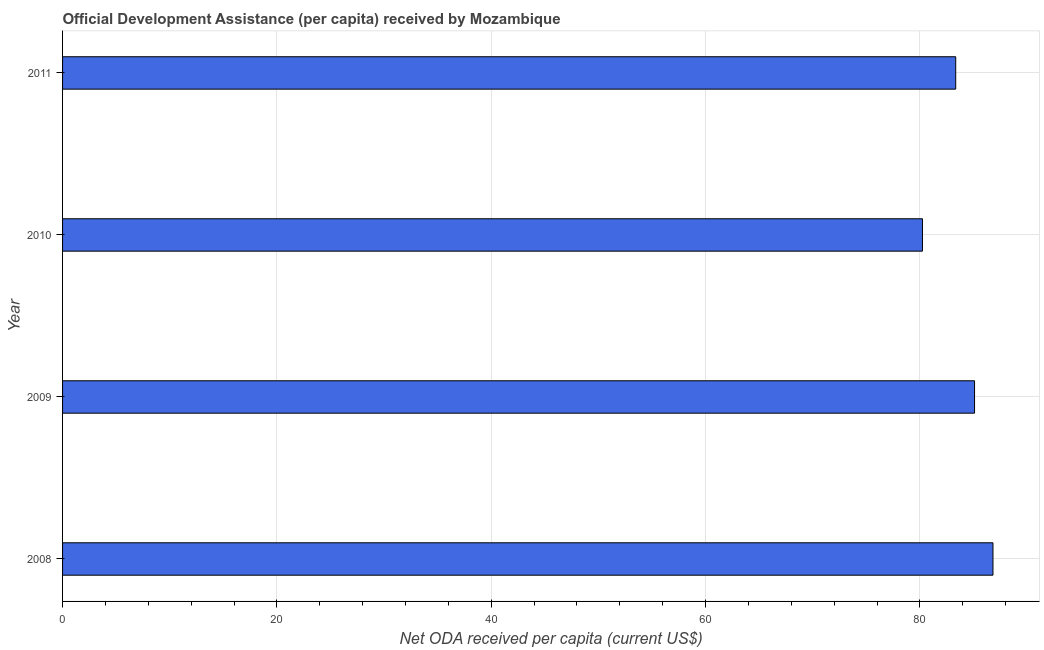Does the graph contain any zero values?
Make the answer very short. No. Does the graph contain grids?
Make the answer very short. Yes. What is the title of the graph?
Your answer should be compact. Official Development Assistance (per capita) received by Mozambique. What is the label or title of the X-axis?
Make the answer very short. Net ODA received per capita (current US$). What is the net oda received per capita in 2008?
Ensure brevity in your answer.  86.82. Across all years, what is the maximum net oda received per capita?
Your response must be concise. 86.82. Across all years, what is the minimum net oda received per capita?
Keep it short and to the point. 80.24. In which year was the net oda received per capita maximum?
Provide a short and direct response. 2008. What is the sum of the net oda received per capita?
Offer a very short reply. 335.5. What is the difference between the net oda received per capita in 2010 and 2011?
Make the answer very short. -3.1. What is the average net oda received per capita per year?
Make the answer very short. 83.88. What is the median net oda received per capita?
Ensure brevity in your answer.  84.22. Do a majority of the years between 2008 and 2009 (inclusive) have net oda received per capita greater than 4 US$?
Give a very brief answer. Yes. What is the ratio of the net oda received per capita in 2009 to that in 2010?
Your answer should be compact. 1.06. What is the difference between the highest and the second highest net oda received per capita?
Your answer should be compact. 1.72. Is the sum of the net oda received per capita in 2008 and 2010 greater than the maximum net oda received per capita across all years?
Offer a terse response. Yes. What is the difference between the highest and the lowest net oda received per capita?
Offer a terse response. 6.58. How many years are there in the graph?
Make the answer very short. 4. What is the difference between two consecutive major ticks on the X-axis?
Offer a very short reply. 20. Are the values on the major ticks of X-axis written in scientific E-notation?
Offer a terse response. No. What is the Net ODA received per capita (current US$) in 2008?
Offer a very short reply. 86.82. What is the Net ODA received per capita (current US$) of 2009?
Offer a terse response. 85.1. What is the Net ODA received per capita (current US$) of 2010?
Offer a very short reply. 80.24. What is the Net ODA received per capita (current US$) in 2011?
Your answer should be compact. 83.34. What is the difference between the Net ODA received per capita (current US$) in 2008 and 2009?
Make the answer very short. 1.72. What is the difference between the Net ODA received per capita (current US$) in 2008 and 2010?
Keep it short and to the point. 6.58. What is the difference between the Net ODA received per capita (current US$) in 2008 and 2011?
Offer a very short reply. 3.48. What is the difference between the Net ODA received per capita (current US$) in 2009 and 2010?
Provide a succinct answer. 4.86. What is the difference between the Net ODA received per capita (current US$) in 2009 and 2011?
Provide a short and direct response. 1.76. What is the difference between the Net ODA received per capita (current US$) in 2010 and 2011?
Provide a short and direct response. -3.1. What is the ratio of the Net ODA received per capita (current US$) in 2008 to that in 2010?
Give a very brief answer. 1.08. What is the ratio of the Net ODA received per capita (current US$) in 2008 to that in 2011?
Offer a very short reply. 1.04. What is the ratio of the Net ODA received per capita (current US$) in 2009 to that in 2010?
Keep it short and to the point. 1.06. What is the ratio of the Net ODA received per capita (current US$) in 2009 to that in 2011?
Your answer should be compact. 1.02. What is the ratio of the Net ODA received per capita (current US$) in 2010 to that in 2011?
Your answer should be very brief. 0.96. 